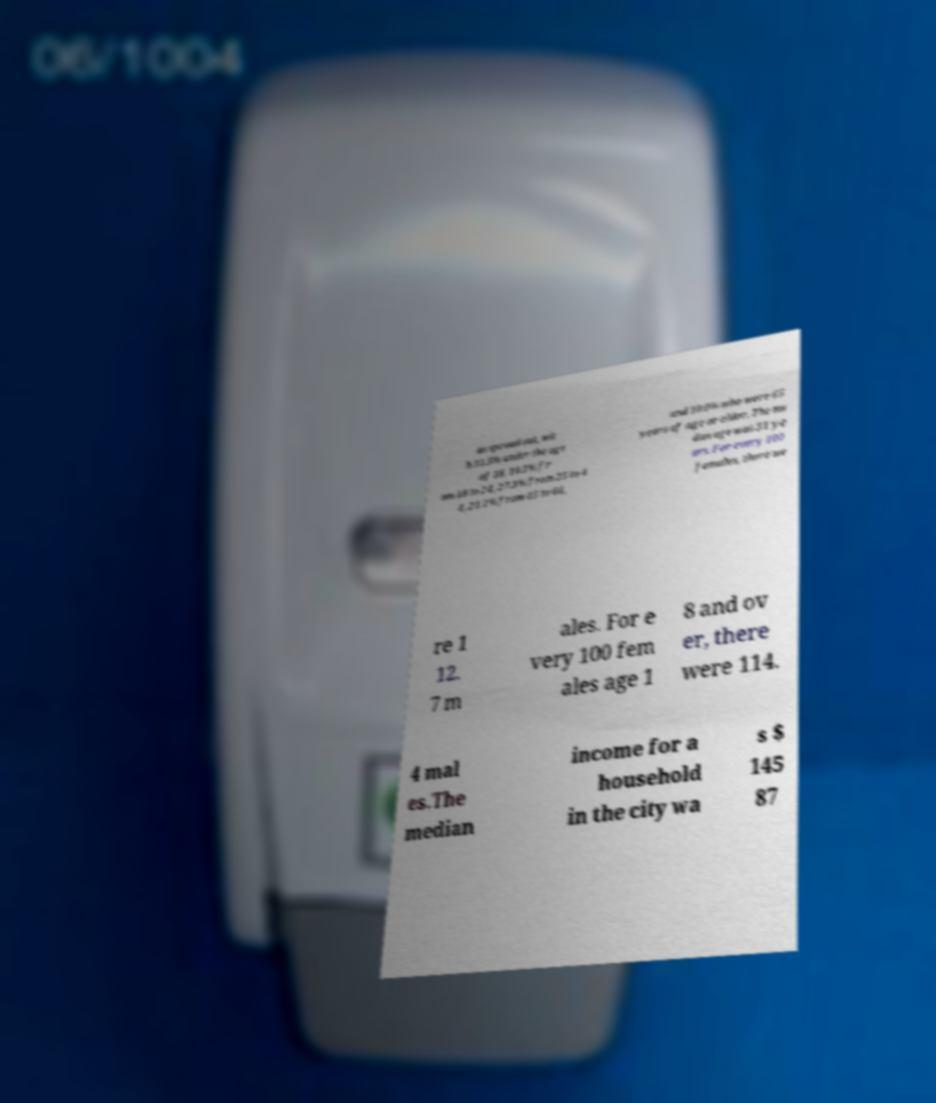Can you read and provide the text displayed in the image?This photo seems to have some interesting text. Can you extract and type it out for me? as spread out, wit h 31.5% under the age of 18, 10.1% fr om 18 to 24, 27.3% from 25 to 4 4, 21.1% from 45 to 64, and 10.0% who were 65 years of age or older. The me dian age was 31 ye ars. For every 100 females, there we re 1 12. 7 m ales. For e very 100 fem ales age 1 8 and ov er, there were 114. 4 mal es.The median income for a household in the city wa s $ 145 87 